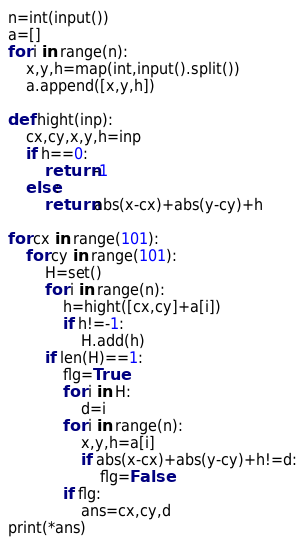Convert code to text. <code><loc_0><loc_0><loc_500><loc_500><_Python_>n=int(input())
a=[]
for i in range(n):
    x,y,h=map(int,input().split())
    a.append([x,y,h])

def hight(inp):
    cx,cy,x,y,h=inp
    if h==0:
        return -1
    else:
        return abs(x-cx)+abs(y-cy)+h
    
for cx in range(101):
    for cy in range(101):
        H=set()
        for i in range(n):
            h=hight([cx,cy]+a[i])
            if h!=-1:
                H.add(h)
        if len(H)==1:
            flg=True
            for i in H:
                d=i
            for i in range(n):
                x,y,h=a[i]
                if abs(x-cx)+abs(y-cy)+h!=d:
                    flg=False
            if flg:
                ans=cx,cy,d
print(*ans)
</code> 